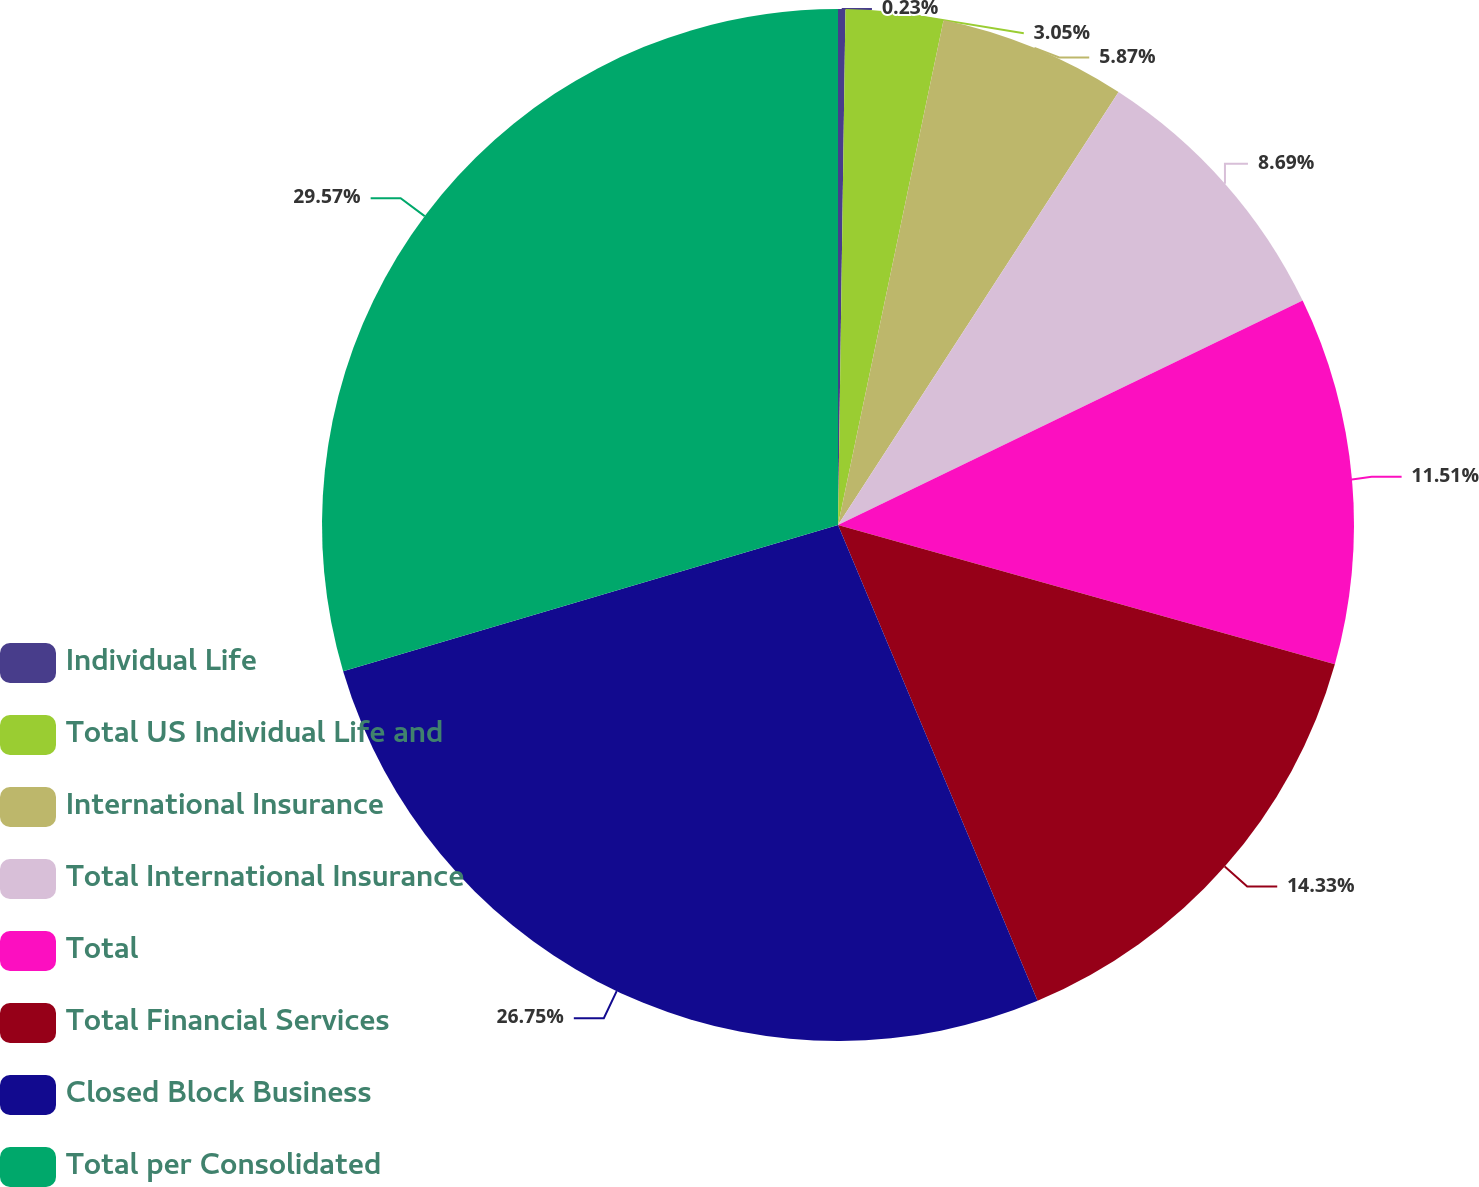Convert chart. <chart><loc_0><loc_0><loc_500><loc_500><pie_chart><fcel>Individual Life<fcel>Total US Individual Life and<fcel>International Insurance<fcel>Total International Insurance<fcel>Total<fcel>Total Financial Services<fcel>Closed Block Business<fcel>Total per Consolidated<nl><fcel>0.23%<fcel>3.05%<fcel>5.87%<fcel>8.69%<fcel>11.51%<fcel>14.33%<fcel>26.75%<fcel>29.57%<nl></chart> 